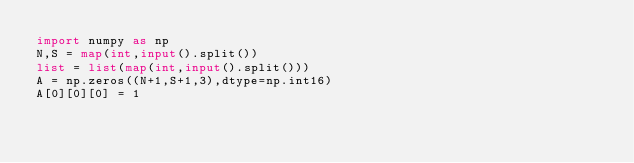Convert code to text. <code><loc_0><loc_0><loc_500><loc_500><_Python_>import numpy as np
N,S = map(int,input().split())
list = list(map(int,input().split()))
A = np.zeros((N+1,S+1,3),dtype=np.int16)
A[0][0][0] = 1
</code> 